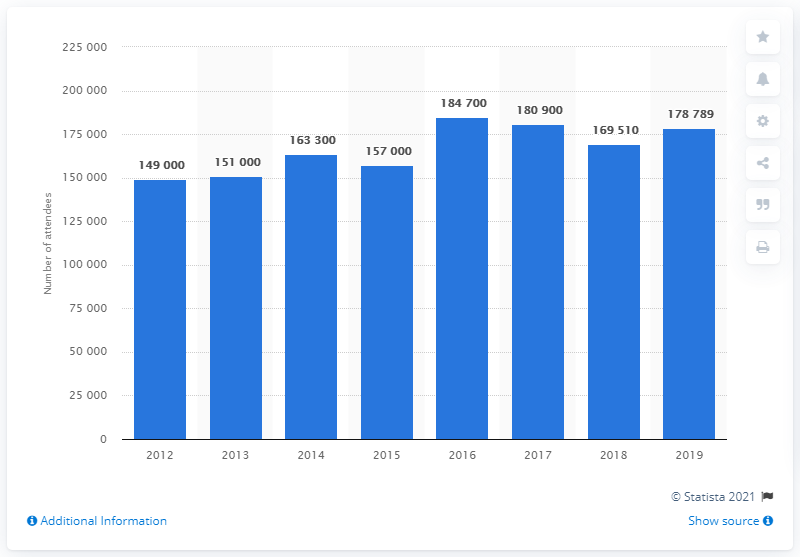List a handful of essential elements in this visual. The BFI London Film Festival was first held in 2012. 